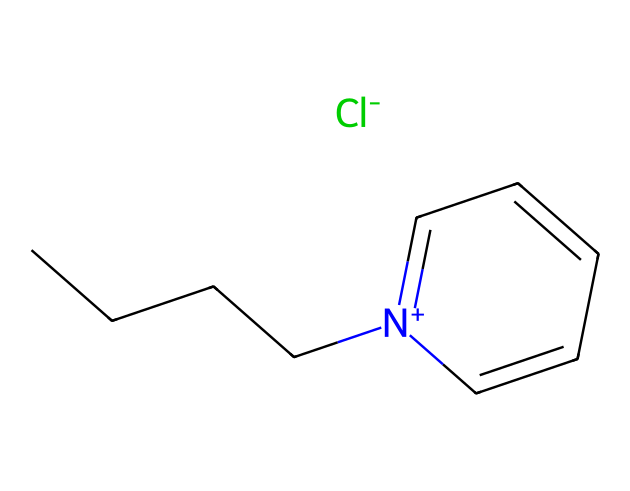What type of ionic liquid is represented by this SMILES notation? The SMILES notation indicates that it is a pyridinium ionic liquid due to the presence of a nitrogen atom carrying a positive charge in a pyridine-like structure.
Answer: pyridinium ionic liquid How many carbon atoms are there in the molecular composition? By examining the structure from the SMILES notation, we identify five carbon atoms in the aromatic ring and four from the butyl chain, totaling nine carbon atoms.
Answer: 9 What is the charge of the cation in this ionic liquid? The notation '[n+]' indicates that the nitrogen atom in the pyridinium moiety carries a positive charge.
Answer: +1 Which component indicates the presence of the chloride ion? The '[Cl-]' part of the SMILES representation denotes the presence of a negatively charged chloride ion in the ionic liquid.
Answer: Cl- What property does the butyl chain contribute to this ionic liquid? The butyl group provides hydrophobic characteristics, enhancing the solubility of the ionic liquid in nonpolar solvents and affecting its fire-resistant properties.
Answer: hydrophobicity What bond type is primarily present in the ionic liquid structure? This ionic liquid predominantly features covalent bonds within the cation and the anion, as indicated by the connections between atoms in the SMILES representation.
Answer: covalent 